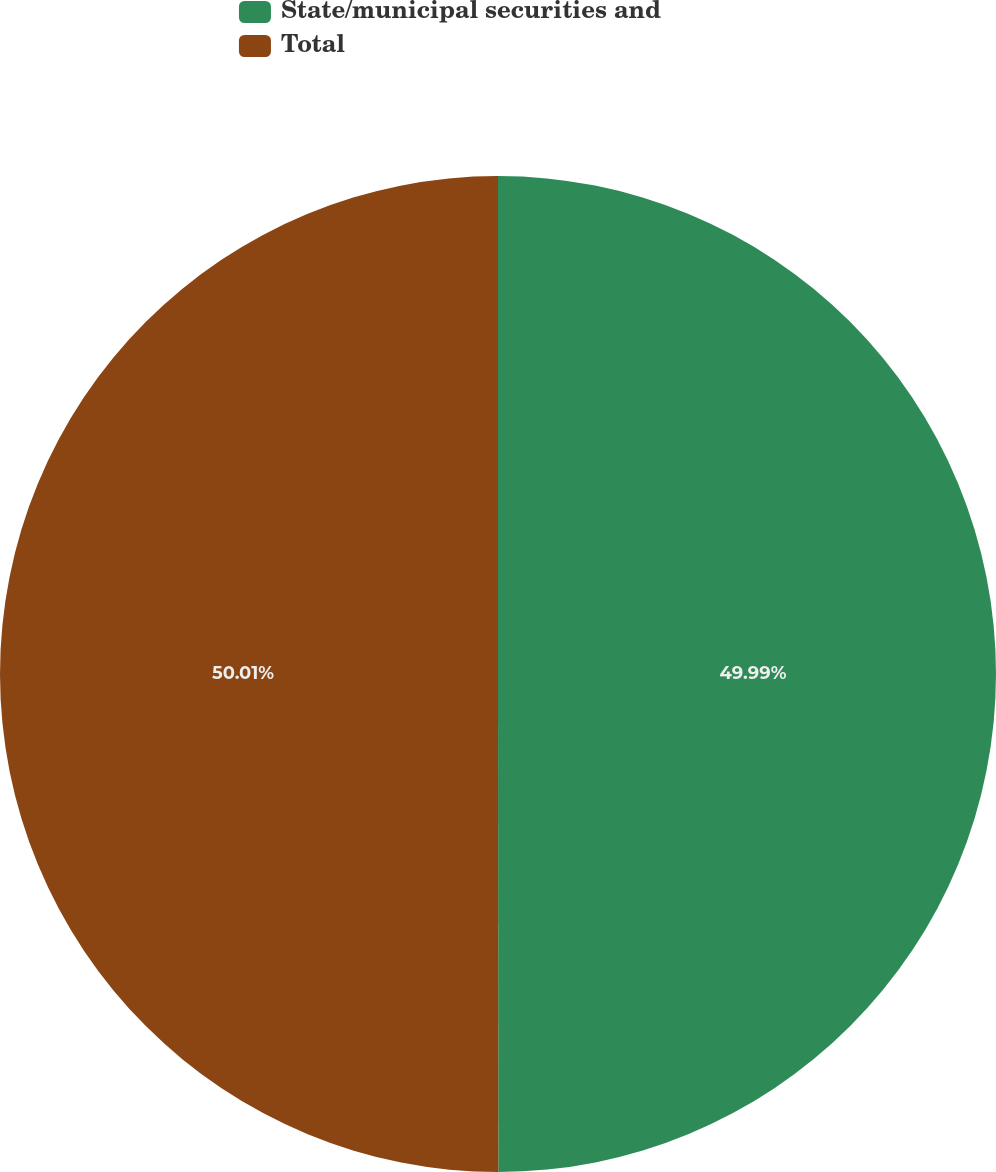Convert chart to OTSL. <chart><loc_0><loc_0><loc_500><loc_500><pie_chart><fcel>State/municipal securities and<fcel>Total<nl><fcel>49.99%<fcel>50.01%<nl></chart> 